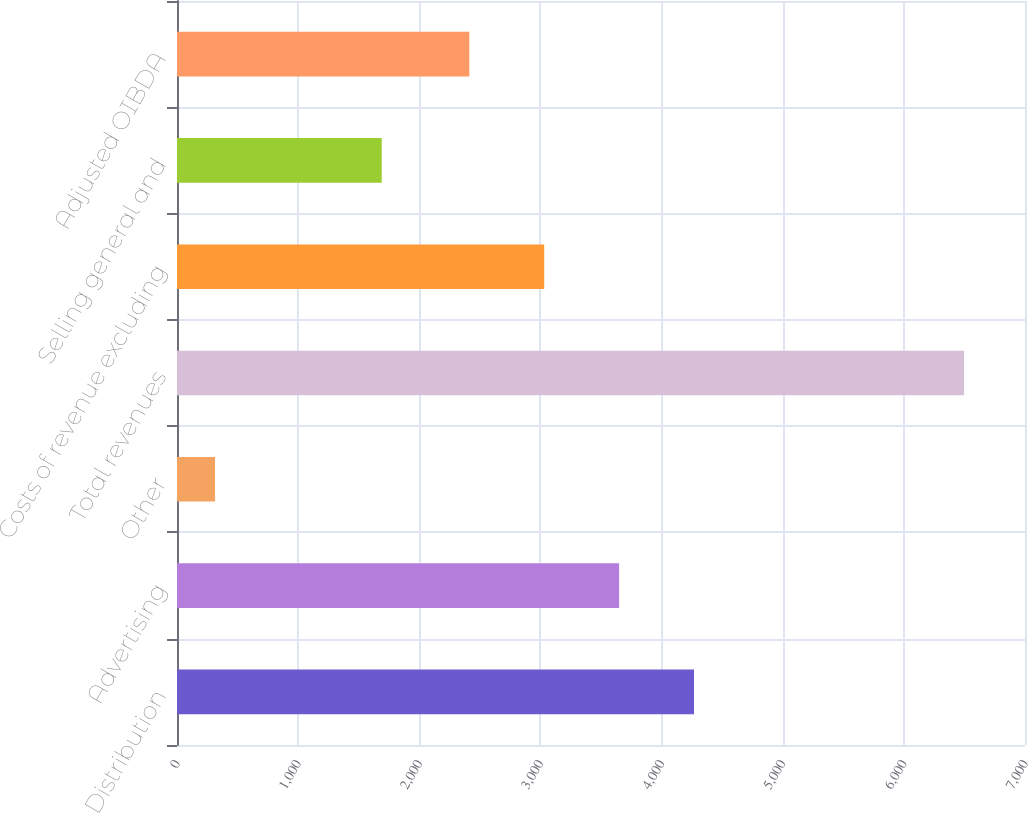<chart> <loc_0><loc_0><loc_500><loc_500><bar_chart><fcel>Distribution<fcel>Advertising<fcel>Other<fcel>Total revenues<fcel>Costs of revenue excluding<fcel>Selling general and<fcel>Adjusted OIBDA<nl><fcel>4267.9<fcel>3649.6<fcel>314<fcel>6497<fcel>3031.3<fcel>1690<fcel>2413<nl></chart> 